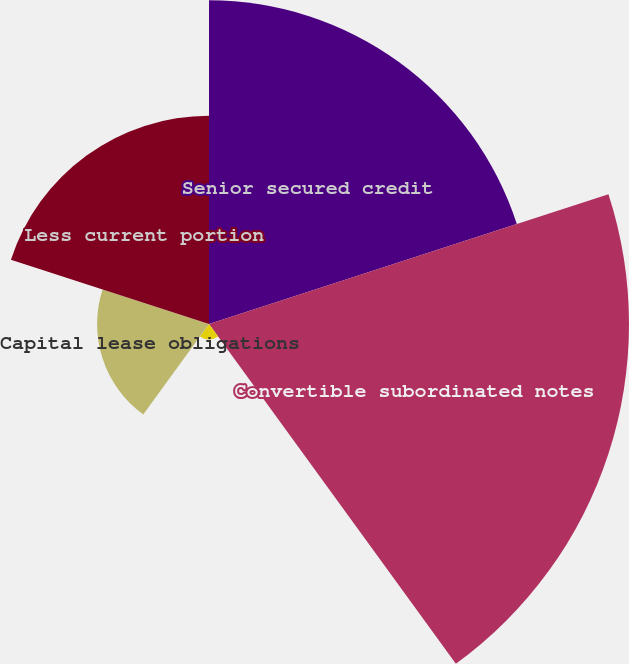Convert chart. <chart><loc_0><loc_0><loc_500><loc_500><pie_chart><fcel>Senior secured credit<fcel>Convertible subordinated notes<fcel>Acquisition obligations and<fcel>Capital lease obligations<fcel>Less current portion<nl><fcel>29.99%<fcel>38.92%<fcel>1.43%<fcel>10.37%<fcel>19.3%<nl></chart> 